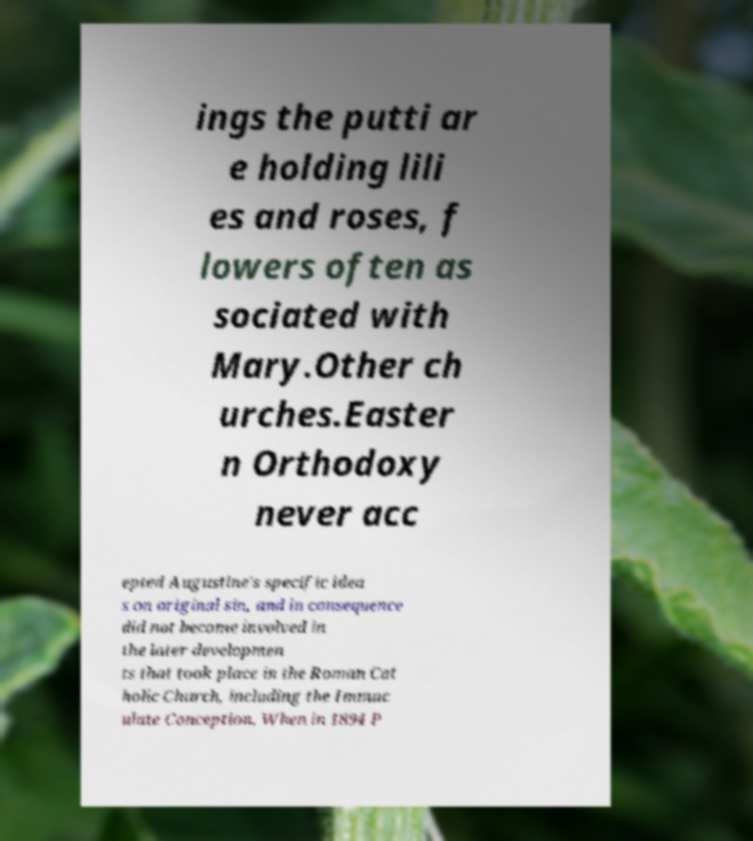Can you read and provide the text displayed in the image?This photo seems to have some interesting text. Can you extract and type it out for me? ings the putti ar e holding lili es and roses, f lowers often as sociated with Mary.Other ch urches.Easter n Orthodoxy never acc epted Augustine's specific idea s on original sin, and in consequence did not become involved in the later developmen ts that took place in the Roman Cat holic Church, including the Immac ulate Conception. When in 1894 P 